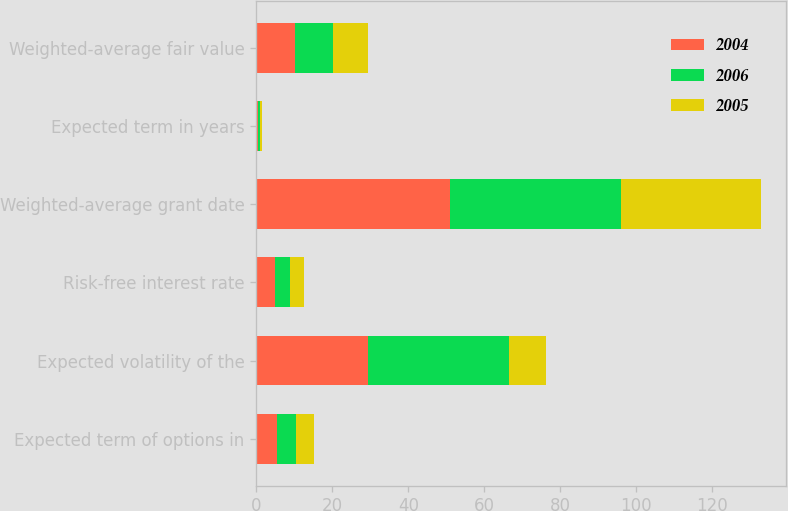Convert chart. <chart><loc_0><loc_0><loc_500><loc_500><stacked_bar_chart><ecel><fcel>Expected term of options in<fcel>Expected volatility of the<fcel>Risk-free interest rate<fcel>Weighted-average grant date<fcel>Expected term in years<fcel>Weighted-average fair value<nl><fcel>2004<fcel>5.3<fcel>29.4<fcel>4.77<fcel>50.84<fcel>0.5<fcel>10.07<nl><fcel>2006<fcel>5.1<fcel>37.1<fcel>4.05<fcel>45.12<fcel>0.5<fcel>10.08<nl><fcel>2005<fcel>4.7<fcel>9.64<fcel>3.58<fcel>36.81<fcel>0.5<fcel>9.21<nl></chart> 